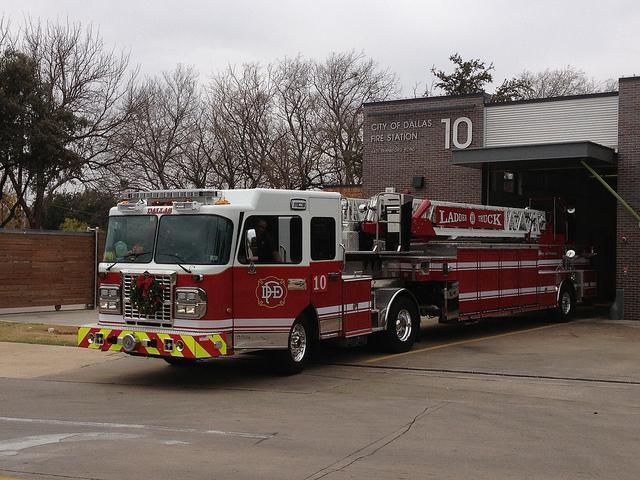How many cars are in this scene?
Give a very brief answer. 1. How many boards is the bench made out of?
Give a very brief answer. 0. 